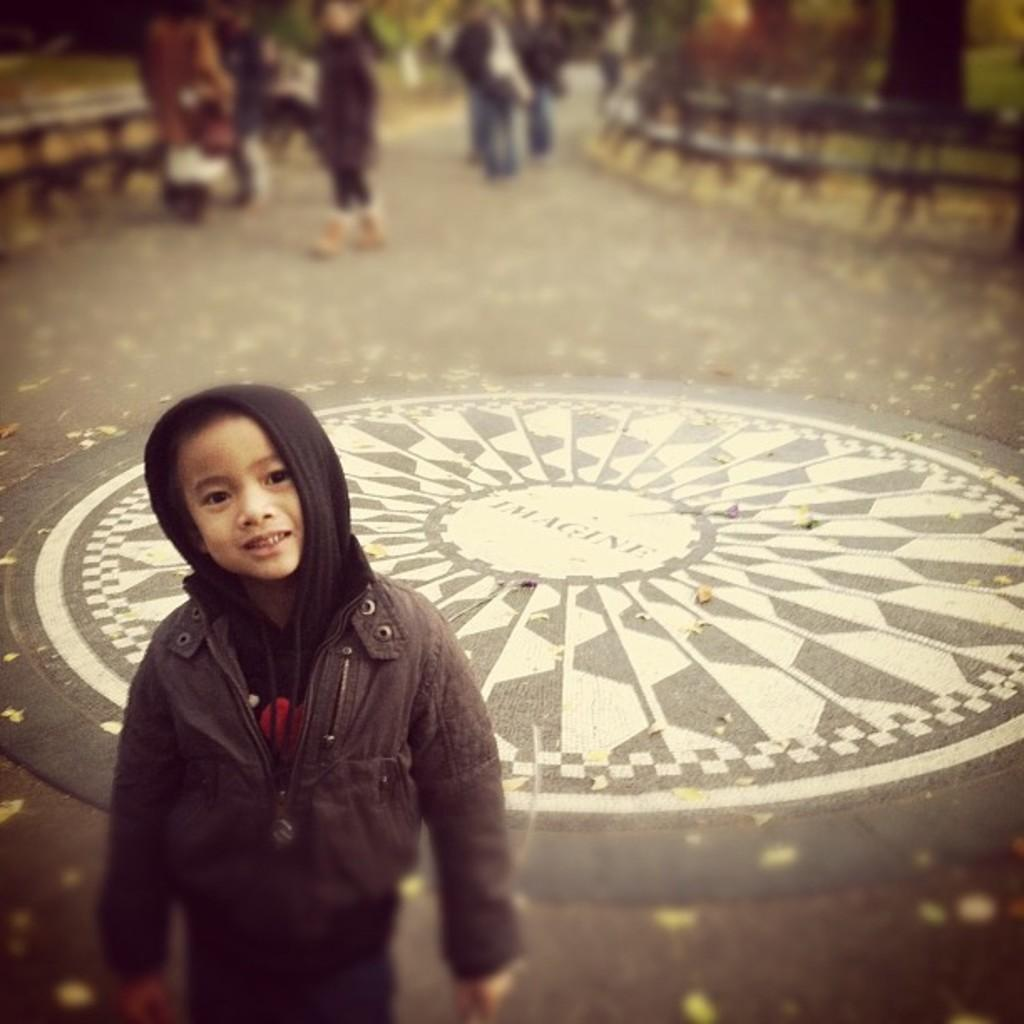Who is the main subject in the image? There is a boy in the image. What is the boy doing in the image? The boy is standing and smiling. What can be seen in the background of the image? There are persons walking in the background of the image. What type of ring can be seen on the boy's finger in the image? There is no ring visible on the boy's finger in the image. What kind of ball is the boy holding in the image? There is no ball present in the image. 